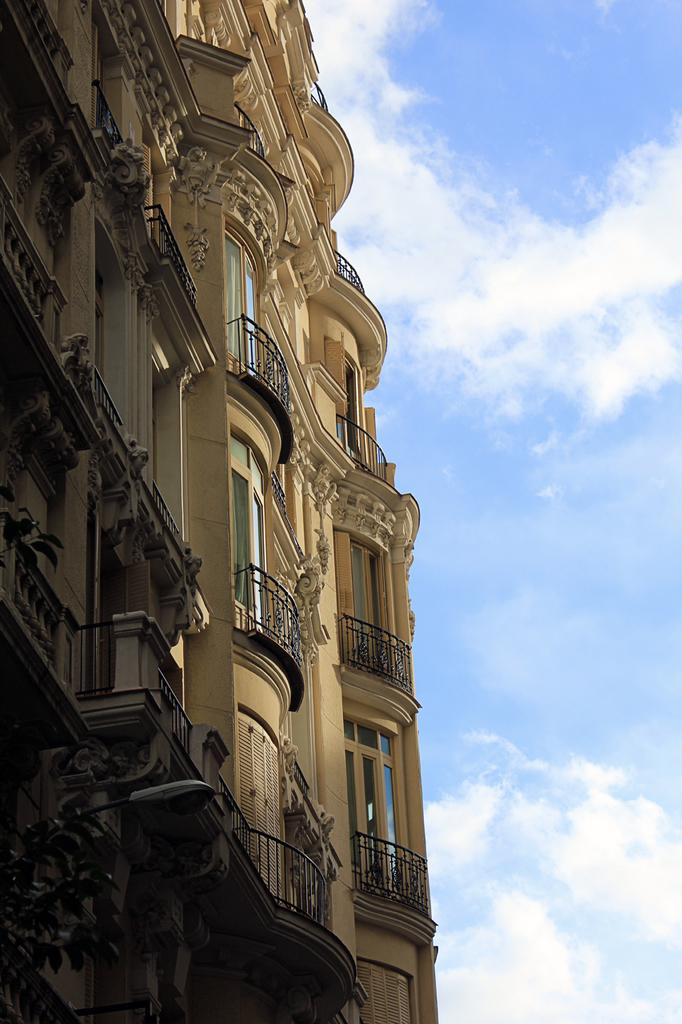What type of structure is present in the image? There is a building in the image. What can be seen in the background of the image? The sky is visible in the background of the image. How many boys are wearing trousers in the image? There are no boys or trousers present in the image. 